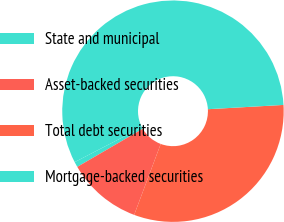Convert chart to OTSL. <chart><loc_0><loc_0><loc_500><loc_500><pie_chart><fcel>State and municipal<fcel>Asset-backed securities<fcel>Total debt securities<fcel>Mortgage-backed securities<nl><fcel>0.78%<fcel>10.91%<fcel>31.6%<fcel>56.71%<nl></chart> 